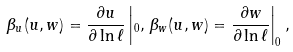<formula> <loc_0><loc_0><loc_500><loc_500>\beta _ { u } ( u , w ) = \frac { \partial u } { \partial \ln \ell } \left | _ { 0 } , \, \beta _ { w } ( u , w ) = \frac { \partial w } { \partial \ln \ell } \right | _ { 0 } ,</formula> 